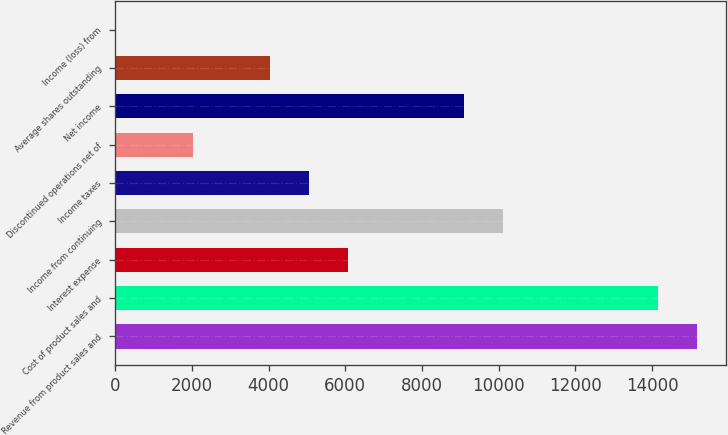Convert chart to OTSL. <chart><loc_0><loc_0><loc_500><loc_500><bar_chart><fcel>Revenue from product sales and<fcel>Cost of product sales and<fcel>Interest expense<fcel>Income from continuing<fcel>Income taxes<fcel>Discontinued operations net of<fcel>Net income<fcel>Average shares outstanding<fcel>Income (loss) from<nl><fcel>15175.5<fcel>14163.8<fcel>6070.23<fcel>10117<fcel>5058.53<fcel>2023.43<fcel>9105.33<fcel>4046.83<fcel>0.03<nl></chart> 